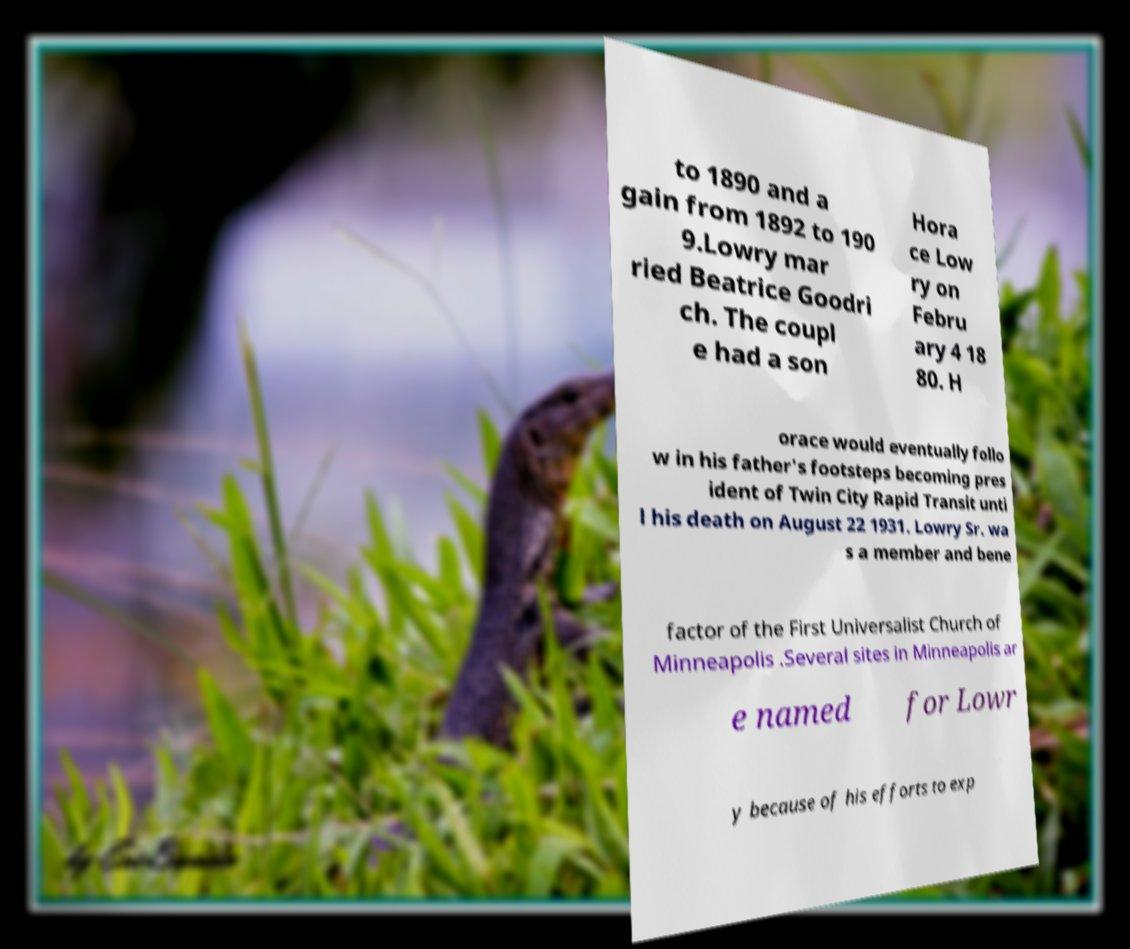Could you extract and type out the text from this image? to 1890 and a gain from 1892 to 190 9.Lowry mar ried Beatrice Goodri ch. The coupl e had a son Hora ce Low ry on Febru ary 4 18 80. H orace would eventually follo w in his father's footsteps becoming pres ident of Twin City Rapid Transit unti l his death on August 22 1931. Lowry Sr. wa s a member and bene factor of the First Universalist Church of Minneapolis .Several sites in Minneapolis ar e named for Lowr y because of his efforts to exp 